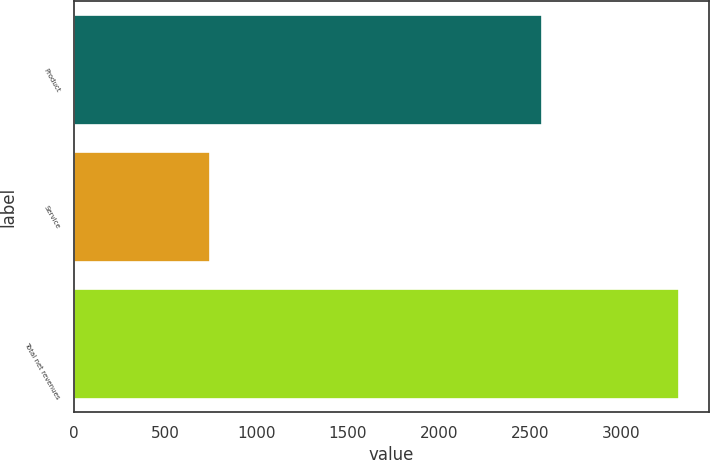Convert chart to OTSL. <chart><loc_0><loc_0><loc_500><loc_500><bar_chart><fcel>Product<fcel>Service<fcel>Total net revenues<nl><fcel>2568<fcel>747.9<fcel>3315.9<nl></chart> 